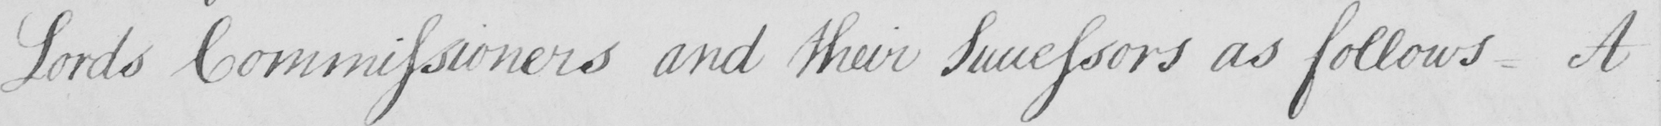Please provide the text content of this handwritten line. Lords Commissioners and their Successors as follows . A 